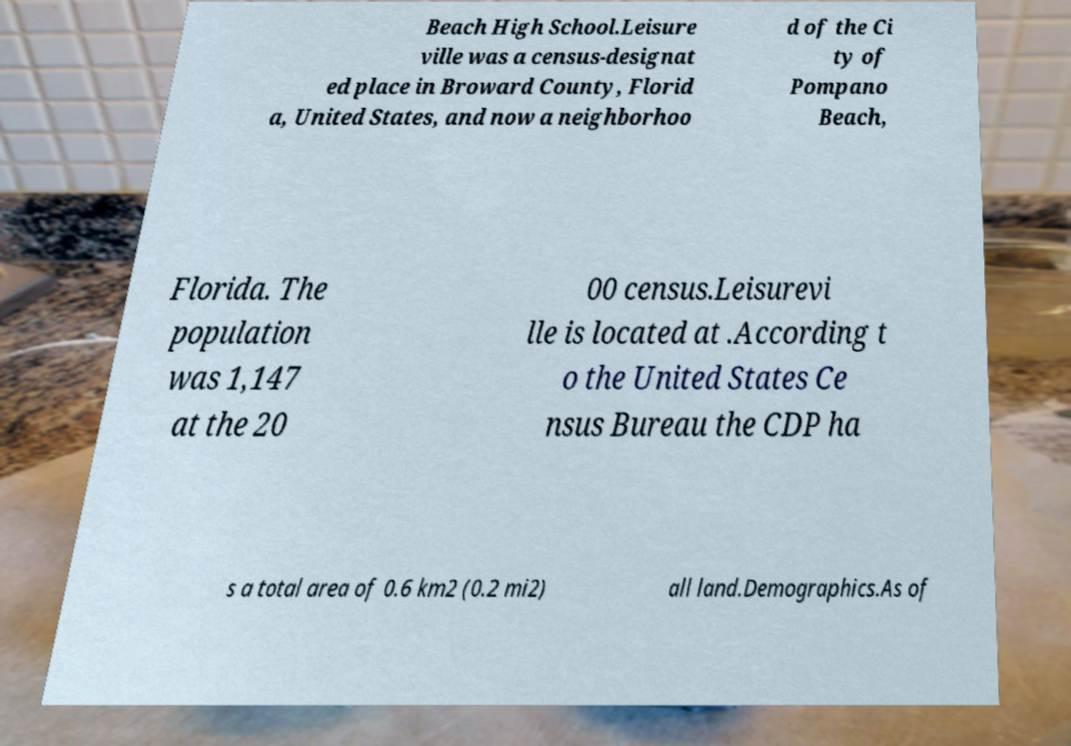I need the written content from this picture converted into text. Can you do that? Beach High School.Leisure ville was a census-designat ed place in Broward County, Florid a, United States, and now a neighborhoo d of the Ci ty of Pompano Beach, Florida. The population was 1,147 at the 20 00 census.Leisurevi lle is located at .According t o the United States Ce nsus Bureau the CDP ha s a total area of 0.6 km2 (0.2 mi2) all land.Demographics.As of 